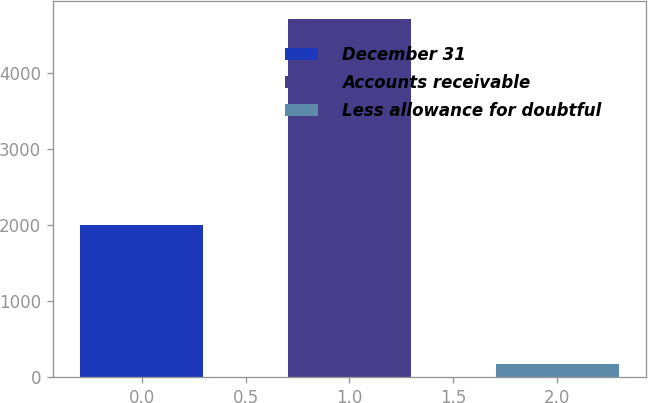Convert chart to OTSL. <chart><loc_0><loc_0><loc_500><loc_500><bar_chart><fcel>December 31<fcel>Accounts receivable<fcel>Less allowance for doubtful<nl><fcel>2004<fcel>4707<fcel>182<nl></chart> 